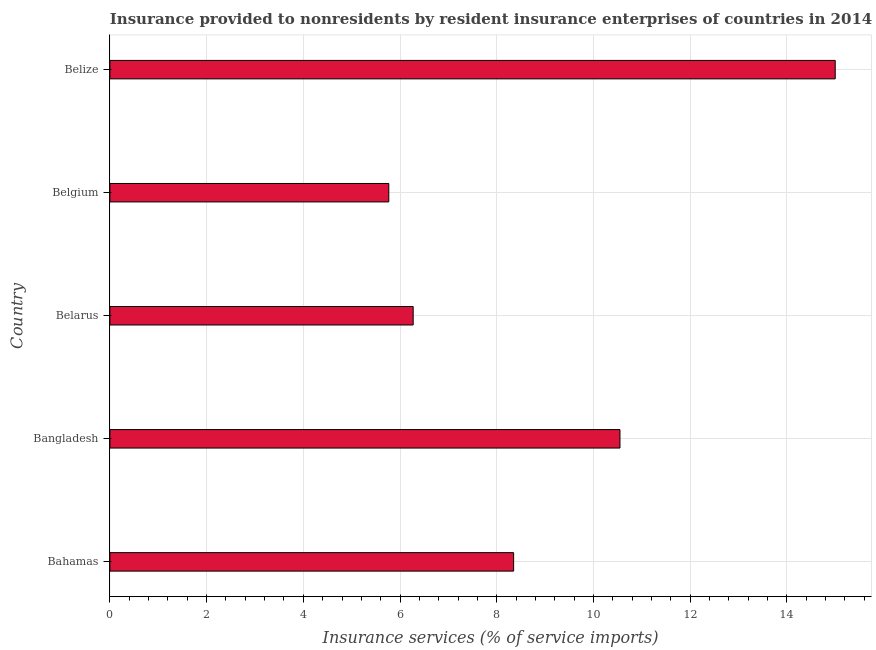Does the graph contain any zero values?
Offer a terse response. No. Does the graph contain grids?
Keep it short and to the point. Yes. What is the title of the graph?
Keep it short and to the point. Insurance provided to nonresidents by resident insurance enterprises of countries in 2014. What is the label or title of the X-axis?
Offer a very short reply. Insurance services (% of service imports). What is the insurance and financial services in Bangladesh?
Ensure brevity in your answer.  10.55. Across all countries, what is the maximum insurance and financial services?
Offer a terse response. 15. Across all countries, what is the minimum insurance and financial services?
Keep it short and to the point. 5.77. In which country was the insurance and financial services maximum?
Your response must be concise. Belize. In which country was the insurance and financial services minimum?
Offer a very short reply. Belgium. What is the sum of the insurance and financial services?
Keep it short and to the point. 45.93. What is the difference between the insurance and financial services in Bangladesh and Belgium?
Make the answer very short. 4.78. What is the average insurance and financial services per country?
Your response must be concise. 9.19. What is the median insurance and financial services?
Offer a terse response. 8.35. What is the ratio of the insurance and financial services in Bahamas to that in Belarus?
Ensure brevity in your answer.  1.33. Is the insurance and financial services in Belgium less than that in Belize?
Provide a short and direct response. Yes. Is the difference between the insurance and financial services in Belgium and Belize greater than the difference between any two countries?
Offer a very short reply. Yes. What is the difference between the highest and the second highest insurance and financial services?
Your answer should be very brief. 4.45. Is the sum of the insurance and financial services in Bangladesh and Belarus greater than the maximum insurance and financial services across all countries?
Keep it short and to the point. Yes. What is the difference between the highest and the lowest insurance and financial services?
Your response must be concise. 9.23. How many bars are there?
Make the answer very short. 5. Are all the bars in the graph horizontal?
Make the answer very short. Yes. How many countries are there in the graph?
Your answer should be very brief. 5. Are the values on the major ticks of X-axis written in scientific E-notation?
Your response must be concise. No. What is the Insurance services (% of service imports) of Bahamas?
Give a very brief answer. 8.35. What is the Insurance services (% of service imports) of Bangladesh?
Offer a very short reply. 10.55. What is the Insurance services (% of service imports) of Belarus?
Provide a succinct answer. 6.27. What is the Insurance services (% of service imports) in Belgium?
Keep it short and to the point. 5.77. What is the Insurance services (% of service imports) in Belize?
Your answer should be compact. 15. What is the difference between the Insurance services (% of service imports) in Bahamas and Bangladesh?
Ensure brevity in your answer.  -2.2. What is the difference between the Insurance services (% of service imports) in Bahamas and Belarus?
Make the answer very short. 2.08. What is the difference between the Insurance services (% of service imports) in Bahamas and Belgium?
Provide a short and direct response. 2.58. What is the difference between the Insurance services (% of service imports) in Bahamas and Belize?
Offer a very short reply. -6.65. What is the difference between the Insurance services (% of service imports) in Bangladesh and Belarus?
Offer a terse response. 4.28. What is the difference between the Insurance services (% of service imports) in Bangladesh and Belgium?
Keep it short and to the point. 4.78. What is the difference between the Insurance services (% of service imports) in Bangladesh and Belize?
Your answer should be compact. -4.45. What is the difference between the Insurance services (% of service imports) in Belarus and Belgium?
Make the answer very short. 0.5. What is the difference between the Insurance services (% of service imports) in Belarus and Belize?
Ensure brevity in your answer.  -8.73. What is the difference between the Insurance services (% of service imports) in Belgium and Belize?
Ensure brevity in your answer.  -9.23. What is the ratio of the Insurance services (% of service imports) in Bahamas to that in Bangladesh?
Ensure brevity in your answer.  0.79. What is the ratio of the Insurance services (% of service imports) in Bahamas to that in Belarus?
Your answer should be very brief. 1.33. What is the ratio of the Insurance services (% of service imports) in Bahamas to that in Belgium?
Give a very brief answer. 1.45. What is the ratio of the Insurance services (% of service imports) in Bahamas to that in Belize?
Your answer should be very brief. 0.56. What is the ratio of the Insurance services (% of service imports) in Bangladesh to that in Belarus?
Your answer should be compact. 1.68. What is the ratio of the Insurance services (% of service imports) in Bangladesh to that in Belgium?
Your response must be concise. 1.83. What is the ratio of the Insurance services (% of service imports) in Bangladesh to that in Belize?
Make the answer very short. 0.7. What is the ratio of the Insurance services (% of service imports) in Belarus to that in Belgium?
Your answer should be very brief. 1.09. What is the ratio of the Insurance services (% of service imports) in Belarus to that in Belize?
Keep it short and to the point. 0.42. What is the ratio of the Insurance services (% of service imports) in Belgium to that in Belize?
Provide a succinct answer. 0.39. 